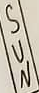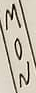Read the text from these images in sequence, separated by a semicolon. SUN; MON 